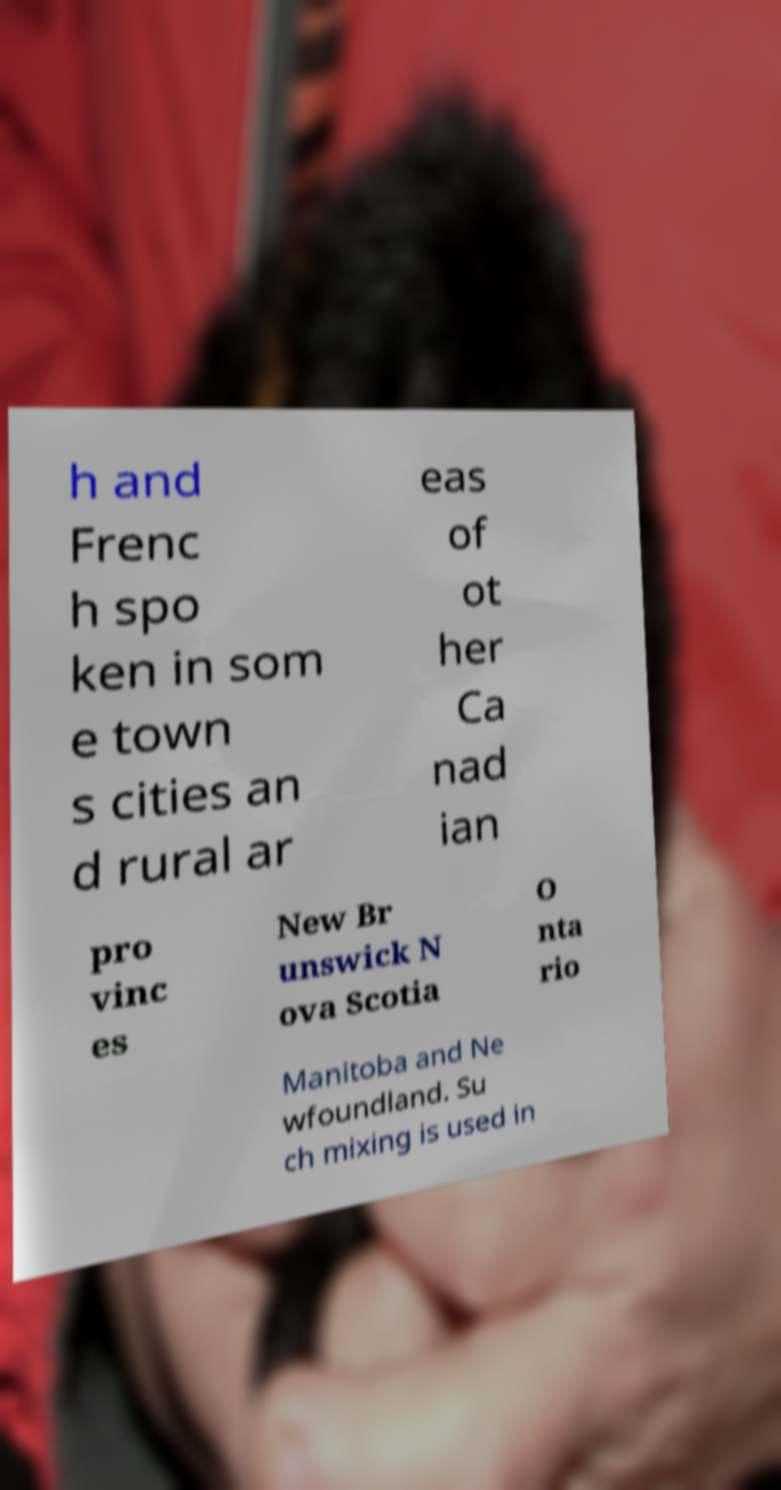Please identify and transcribe the text found in this image. h and Frenc h spo ken in som e town s cities an d rural ar eas of ot her Ca nad ian pro vinc es New Br unswick N ova Scotia O nta rio Manitoba and Ne wfoundland. Su ch mixing is used in 